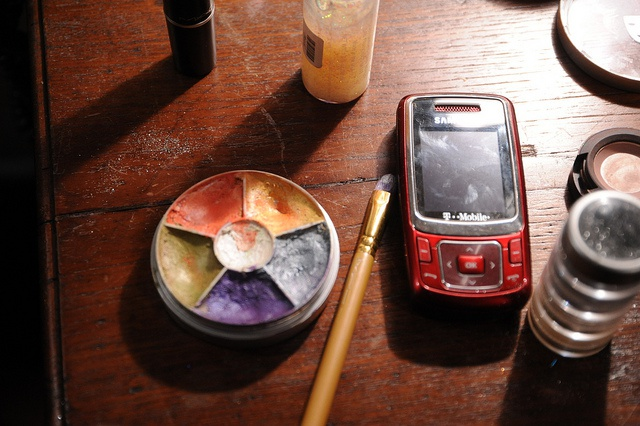Describe the objects in this image and their specific colors. I can see cell phone in black, darkgray, gray, lightgray, and maroon tones and bottle in black, tan, brown, and maroon tones in this image. 